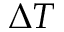Convert formula to latex. <formula><loc_0><loc_0><loc_500><loc_500>\Delta T</formula> 